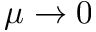Convert formula to latex. <formula><loc_0><loc_0><loc_500><loc_500>\mu \to 0</formula> 